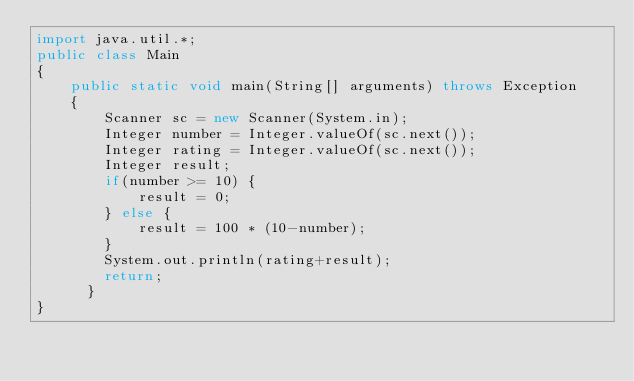Convert code to text. <code><loc_0><loc_0><loc_500><loc_500><_Java_>import java.util.*;
public class Main
{
	public static void main(String[] arguments) throws Exception
	{
		Scanner sc = new Scanner(System.in);
        Integer number = Integer.valueOf(sc.next());
        Integer rating = Integer.valueOf(sc.next());
        Integer result;
        if(number >= 10) {
			result = 0;
		} else {
			result = 100 * (10-number);
		}
		System.out.println(rating+result);
		return;
      }
}</code> 